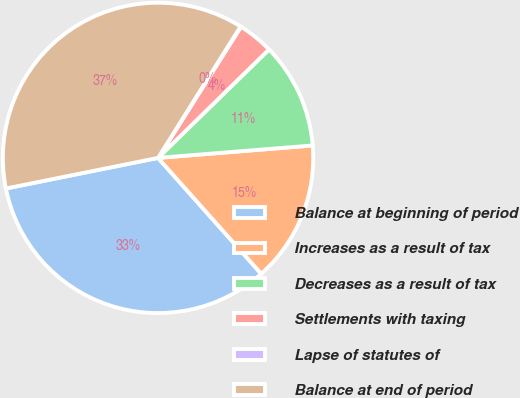Convert chart. <chart><loc_0><loc_0><loc_500><loc_500><pie_chart><fcel>Balance at beginning of period<fcel>Increases as a result of tax<fcel>Decreases as a result of tax<fcel>Settlements with taxing<fcel>Lapse of statutes of<fcel>Balance at end of period<nl><fcel>33.42%<fcel>14.7%<fcel>11.04%<fcel>3.71%<fcel>0.05%<fcel>37.09%<nl></chart> 